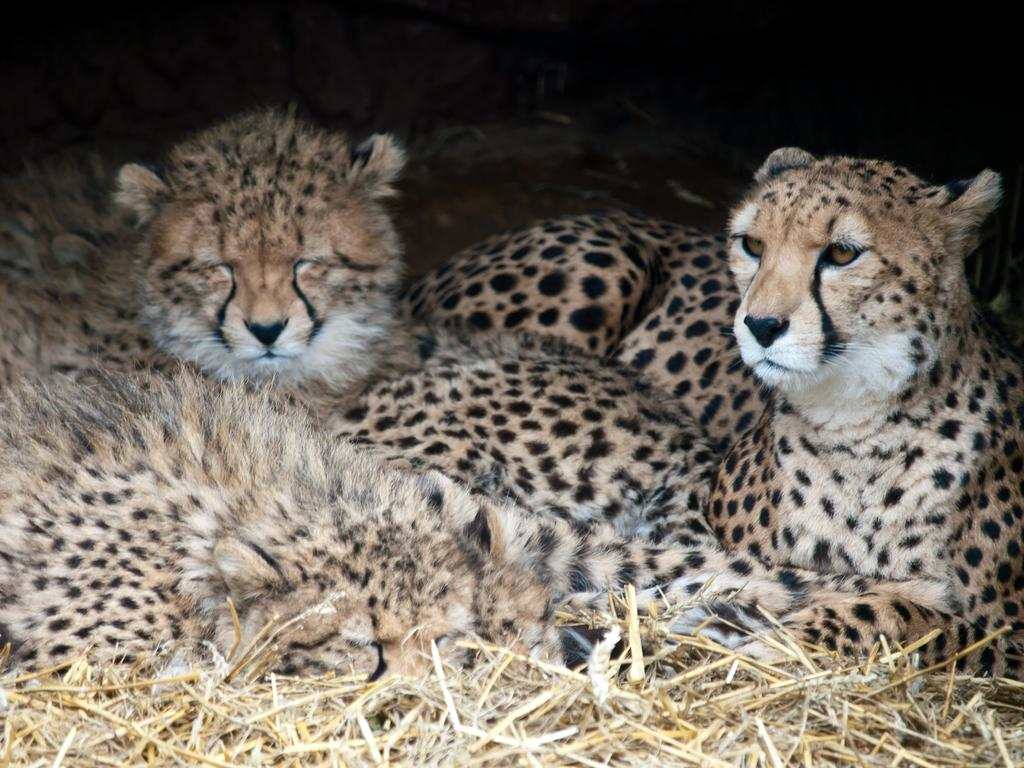What type of animals are in the image? There are tigers in the image. What is the surface on which the tigers are located? The tigers are on the grass. What are the tigers learning in the middle of the image? There is no indication in the image that the tigers are learning anything, nor is there a specific middle area mentioned. How many mice can be seen interacting with the tigers in the image? There are no mice present in the image. 